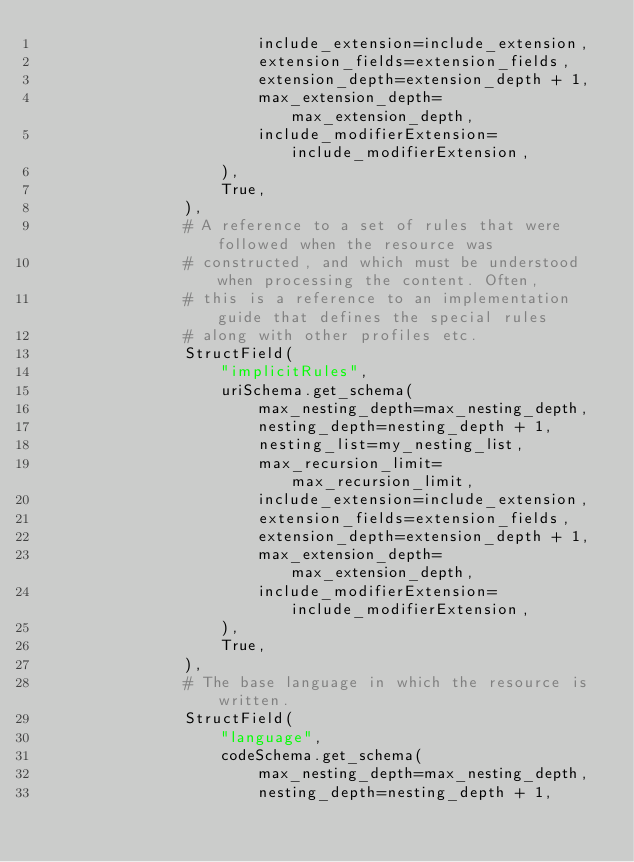Convert code to text. <code><loc_0><loc_0><loc_500><loc_500><_Python_>                        include_extension=include_extension,
                        extension_fields=extension_fields,
                        extension_depth=extension_depth + 1,
                        max_extension_depth=max_extension_depth,
                        include_modifierExtension=include_modifierExtension,
                    ),
                    True,
                ),
                # A reference to a set of rules that were followed when the resource was
                # constructed, and which must be understood when processing the content. Often,
                # this is a reference to an implementation guide that defines the special rules
                # along with other profiles etc.
                StructField(
                    "implicitRules",
                    uriSchema.get_schema(
                        max_nesting_depth=max_nesting_depth,
                        nesting_depth=nesting_depth + 1,
                        nesting_list=my_nesting_list,
                        max_recursion_limit=max_recursion_limit,
                        include_extension=include_extension,
                        extension_fields=extension_fields,
                        extension_depth=extension_depth + 1,
                        max_extension_depth=max_extension_depth,
                        include_modifierExtension=include_modifierExtension,
                    ),
                    True,
                ),
                # The base language in which the resource is written.
                StructField(
                    "language",
                    codeSchema.get_schema(
                        max_nesting_depth=max_nesting_depth,
                        nesting_depth=nesting_depth + 1,</code> 